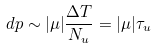Convert formula to latex. <formula><loc_0><loc_0><loc_500><loc_500>d p \sim | \mu | \frac { \Delta T } { N _ { u } } = | \mu | \tau _ { u }</formula> 